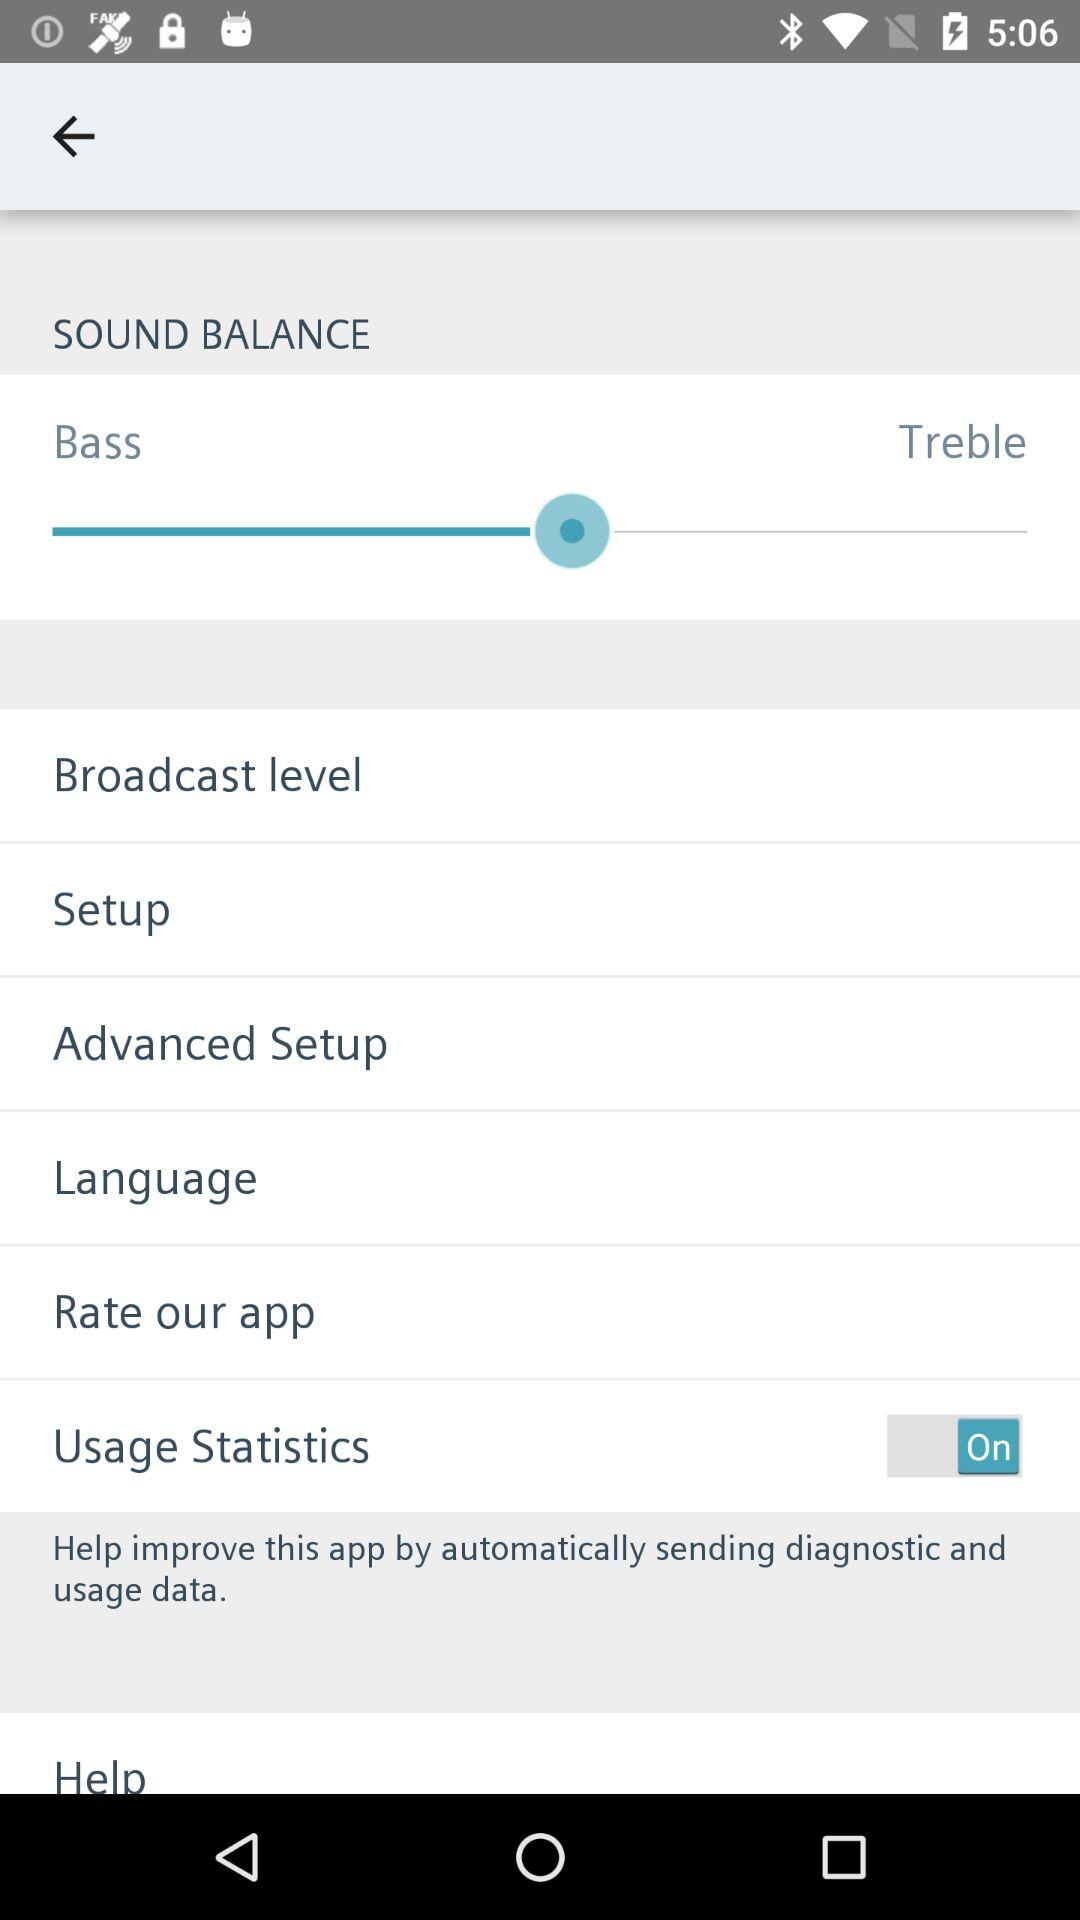What is the status of "Usage Statistics"? The status is "on". 